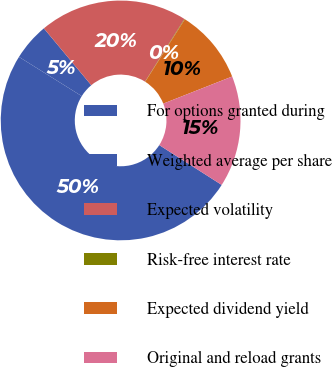Convert chart. <chart><loc_0><loc_0><loc_500><loc_500><pie_chart><fcel>For options granted during<fcel>Weighted average per share<fcel>Expected volatility<fcel>Risk-free interest rate<fcel>Expected dividend yield<fcel>Original and reload grants<nl><fcel>49.86%<fcel>5.05%<fcel>19.99%<fcel>0.07%<fcel>10.03%<fcel>15.01%<nl></chart> 